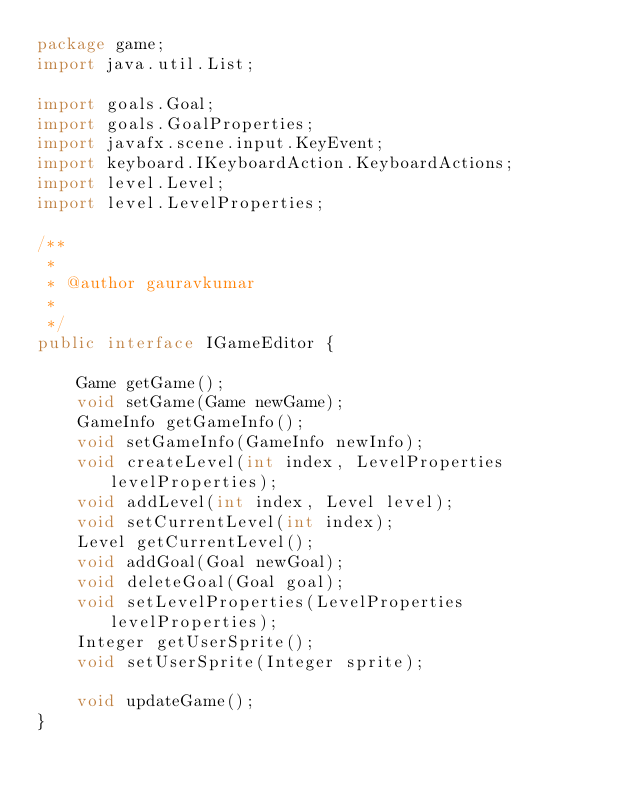<code> <loc_0><loc_0><loc_500><loc_500><_Java_>package game;
import java.util.List;

import goals.Goal;
import goals.GoalProperties;
import javafx.scene.input.KeyEvent;
import keyboard.IKeyboardAction.KeyboardActions;
import level.Level;
import level.LevelProperties;

/**
 * 
 * @author gauravkumar
 *
 */
public interface IGameEditor {
	
	Game getGame();
	void setGame(Game newGame);
	GameInfo getGameInfo();
	void setGameInfo(GameInfo newInfo);
	void createLevel(int index, LevelProperties levelProperties);
	void addLevel(int index, Level level);
	void setCurrentLevel(int index);
	Level getCurrentLevel();
	void addGoal(Goal newGoal);
	void deleteGoal(Goal goal);
	void setLevelProperties(LevelProperties levelProperties);
	Integer getUserSprite();
	void setUserSprite(Integer sprite);
	
    void updateGame();
}
</code> 